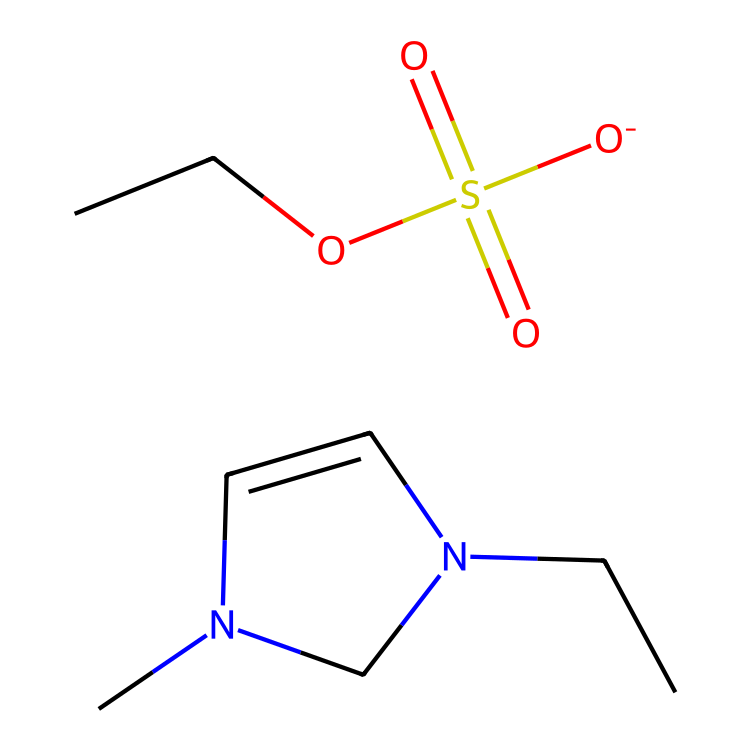What is the molecular formula of 1-ethyl-3-methylimidazolium ethylsulfate? By analyzing the SMILES representation, we count the individual atoms: there are carbon (C), hydrogen (H), nitrogen (N), oxygen (O), and sulfur (S) atoms. The total counts yield the molecular formula C8H15N2O4S.
Answer: C8H15N2O4S How many nitrogen atoms are in the structure? The SMILES representation includes "N" twice, indicating there are two nitrogen atoms in the compound's structure.
Answer: 2 What type of bond is predominantly present between the carbon and nitrogen atoms? Looking closely at the structure, the bond between carbon and nitrogen is primarily a covalent bond due to the nature of these elements sharing electrons.
Answer: covalent What role does the ethyl sulfate group play in this ionic liquid? The presence of the ethyl sulfate group, indicated by "O-]S(=O)(=O)OCC", contributes to the ionic nature and surface-active properties of the liquid, enhancing its ability to reduce surface tension.
Answer: surface-active Is this ionic liquid considered a good solvent? Ionic liquids, including 1-ethyl-3-methylimidazolium ethylsulfate, are known for their solvent abilities, particularly in dissolving a variety of materials due to their unique ionic nature.
Answer: yes What is the significance of the imidazolium ring in the structure? The imidazolium ring contributes to the stability and ionic character of the liquid, making it less volatile and increasing its ability to function in various applications such as fabric softeners.
Answer: stability 